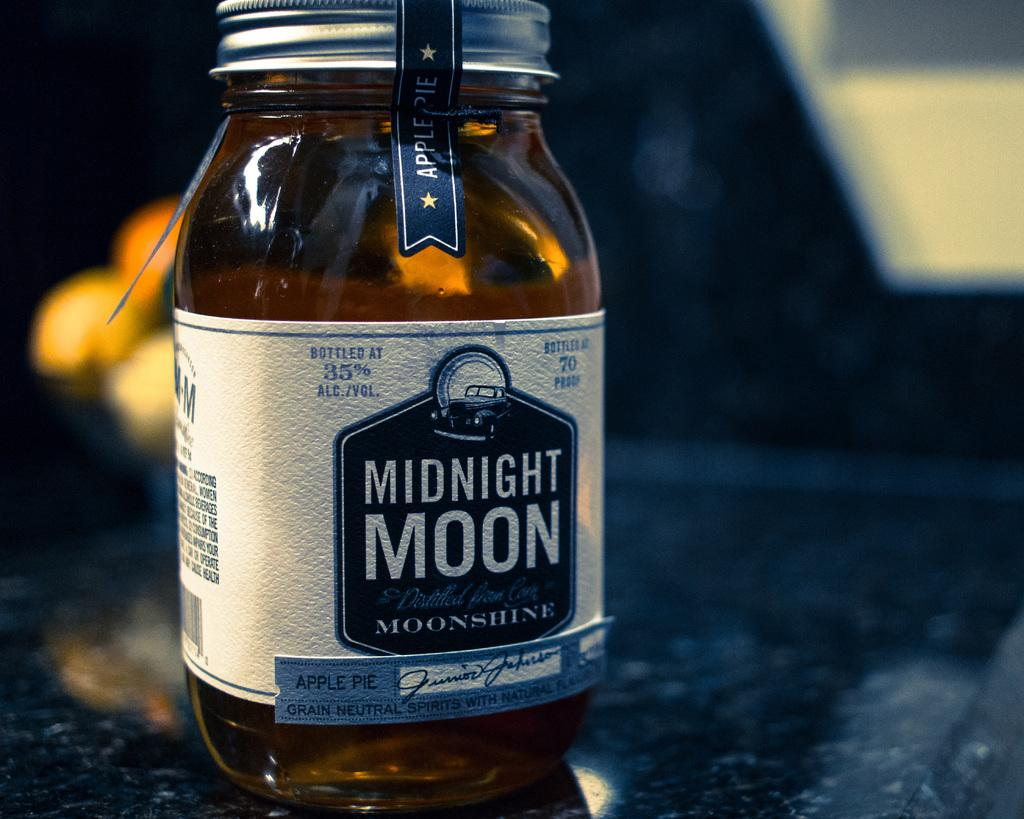<image>
Relay a brief, clear account of the picture shown. A jar of Midnight Moon moonshine is full and still sealed. 